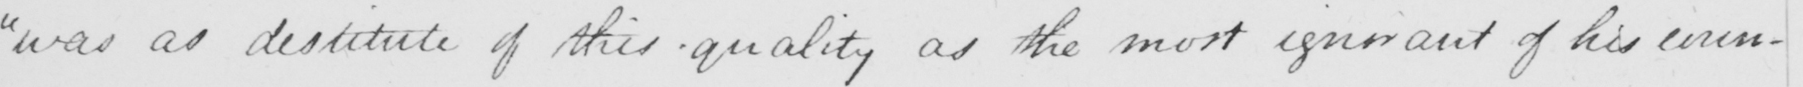Can you tell me what this handwritten text says? "was as destitute of this quality as the most ignorant of his coun- 